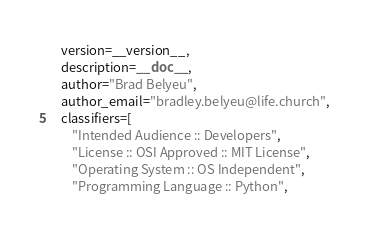<code> <loc_0><loc_0><loc_500><loc_500><_Python_>    version=__version__,
    description=__doc__,
    author="Brad Belyeu",
    author_email="bradley.belyeu@life.church",
    classifiers=[
        "Intended Audience :: Developers",
        "License :: OSI Approved :: MIT License",
        "Operating System :: OS Independent",
        "Programming Language :: Python",</code> 